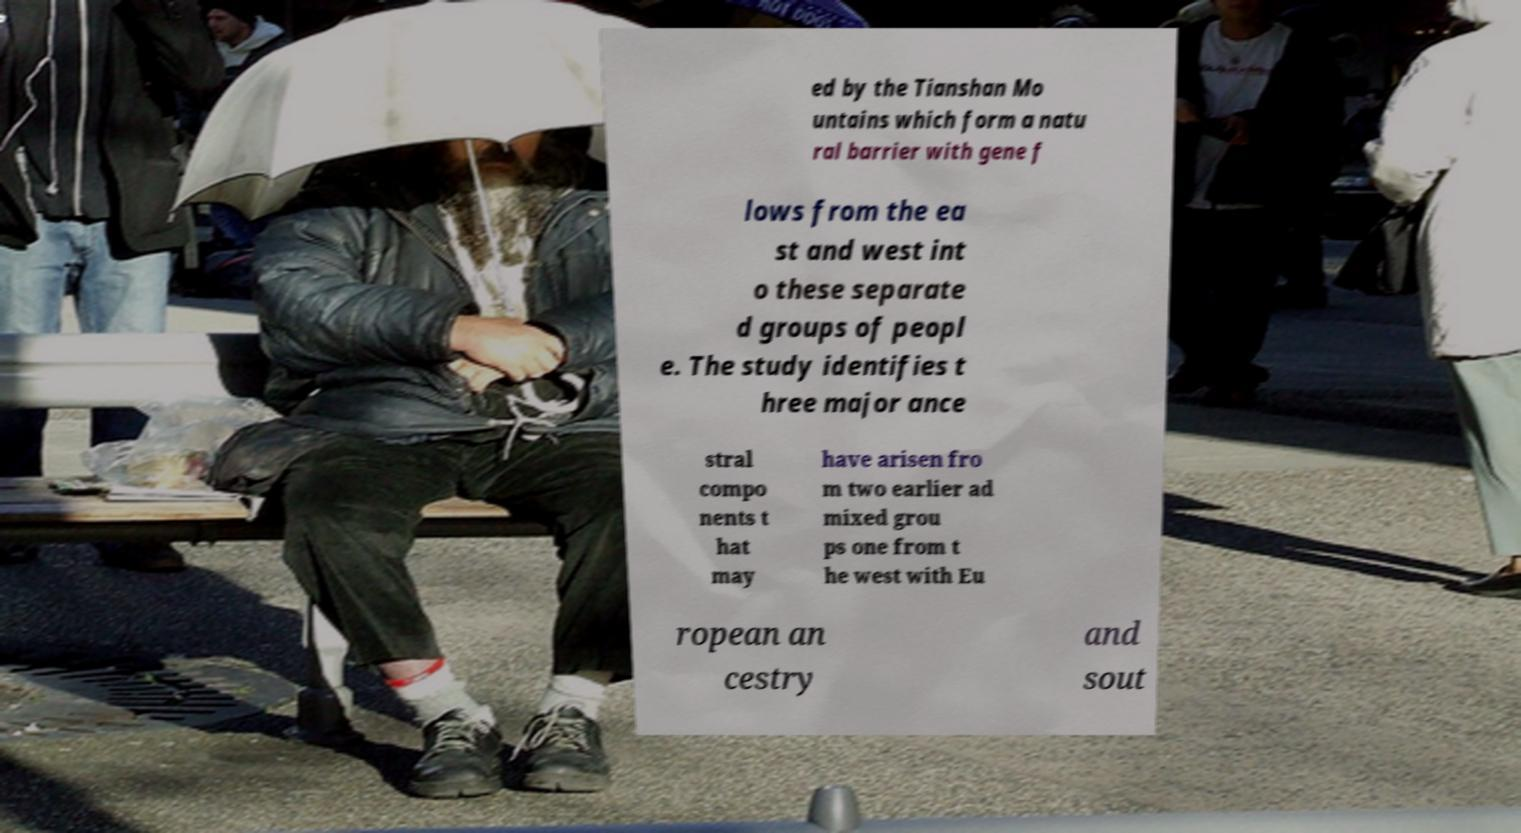Can you accurately transcribe the text from the provided image for me? ed by the Tianshan Mo untains which form a natu ral barrier with gene f lows from the ea st and west int o these separate d groups of peopl e. The study identifies t hree major ance stral compo nents t hat may have arisen fro m two earlier ad mixed grou ps one from t he west with Eu ropean an cestry and sout 